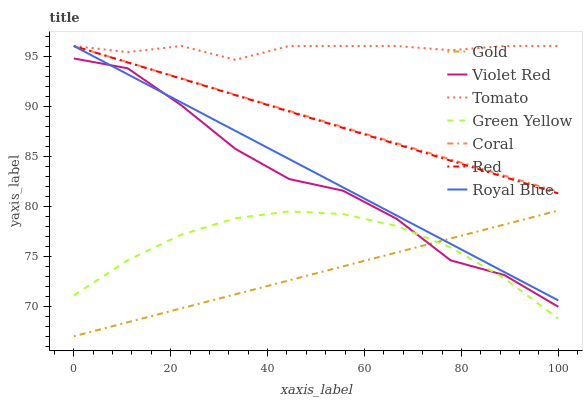Does Violet Red have the minimum area under the curve?
Answer yes or no. No. Does Violet Red have the maximum area under the curve?
Answer yes or no. No. Is Gold the smoothest?
Answer yes or no. No. Is Gold the roughest?
Answer yes or no. No. Does Violet Red have the lowest value?
Answer yes or no. No. Does Violet Red have the highest value?
Answer yes or no. No. Is Gold less than Tomato?
Answer yes or no. Yes. Is Coral greater than Green Yellow?
Answer yes or no. Yes. Does Gold intersect Tomato?
Answer yes or no. No. 